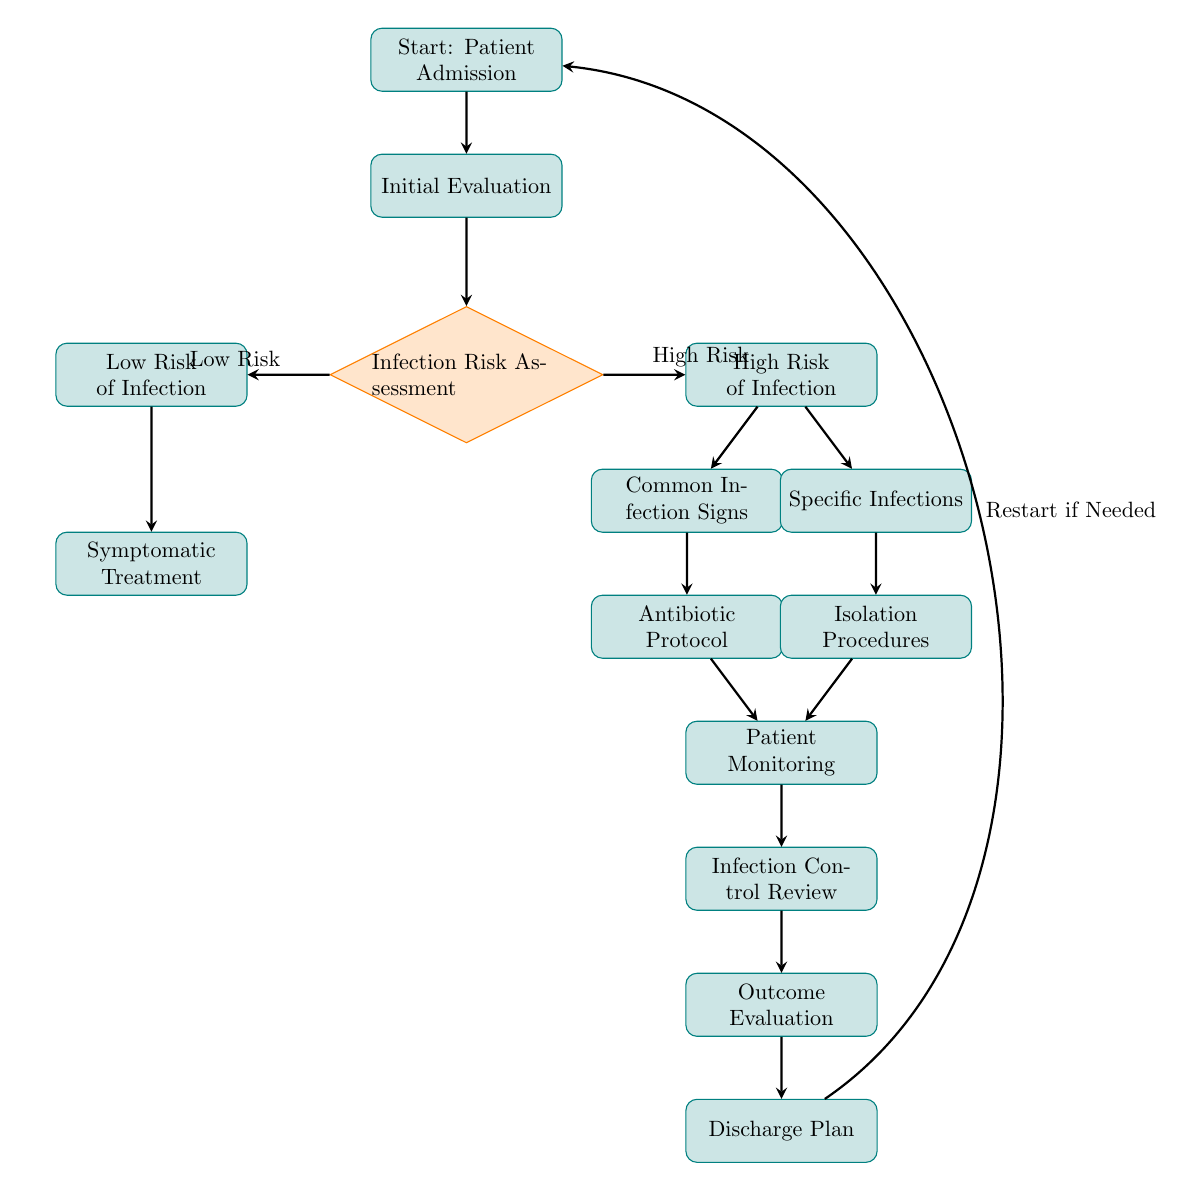What is the first step in the infection control protocol? The diagram shows that the first step in the infection control protocol is "Patient Admission", which is the starting node.
Answer: Patient Admission How many risks categories are assessed after the initial evaluation? There are two categories assessed after "Initial Evaluation": "Low Risk of Infection" and "High Risk of Infection", which are branch nodes connected to "Infection Risk Assessment".
Answer: Two If the assessment indicates a low risk of infection, what is the next process? For "Low Risk of Infection," the following node is "Symptomatic Treatment", which is the only process outlined for this risk level.
Answer: Symptomatic Treatment What happens after identifying common infection signs? After identifying "Common Infection Signs", the next process is "Antibiotic Protocol", which is linked directly beneath it in the flow.
Answer: Antibiotic Protocol Which process comes after the patient monitoring step? Following "Patient Monitoring", the next step in the flow is "Infection Control Review". This indicates that monitoring is succeeded by a review process.
Answer: Infection Control Review What can lead to a return to the start of the protocol? A "Discharge Plan" can lead to a restart of the protocol if needed, indicating that a clinician may decide to re-evaluate based on outcomes or continued symptoms.
Answer: Restart if Needed What type of infection procedures are there after a high-risk assessment? The two types of procedures listed after a "High Risk of Infection" assessment are "Common Infection Signs" and "Specific Infections", providing different pathways for treatment.
Answer: Common Infection Signs, Specific Infections What is the last process in the infection control protocol? The final process in the diagram is "Discharge Plan", which suggests the conclusion of the protocol and plans for the patient's exit from care.
Answer: Discharge Plan If a patient shows "Specific Infections," what is the next intervention? The next intervention after identifying "Specific Infections" is the "Isolation Procedures," as illustrated directly beneath that node.
Answer: Isolation Procedures 